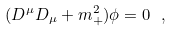Convert formula to latex. <formula><loc_0><loc_0><loc_500><loc_500>( D ^ { \mu } D _ { \mu } + m _ { + } ^ { 2 } ) \phi = 0 \ ,</formula> 